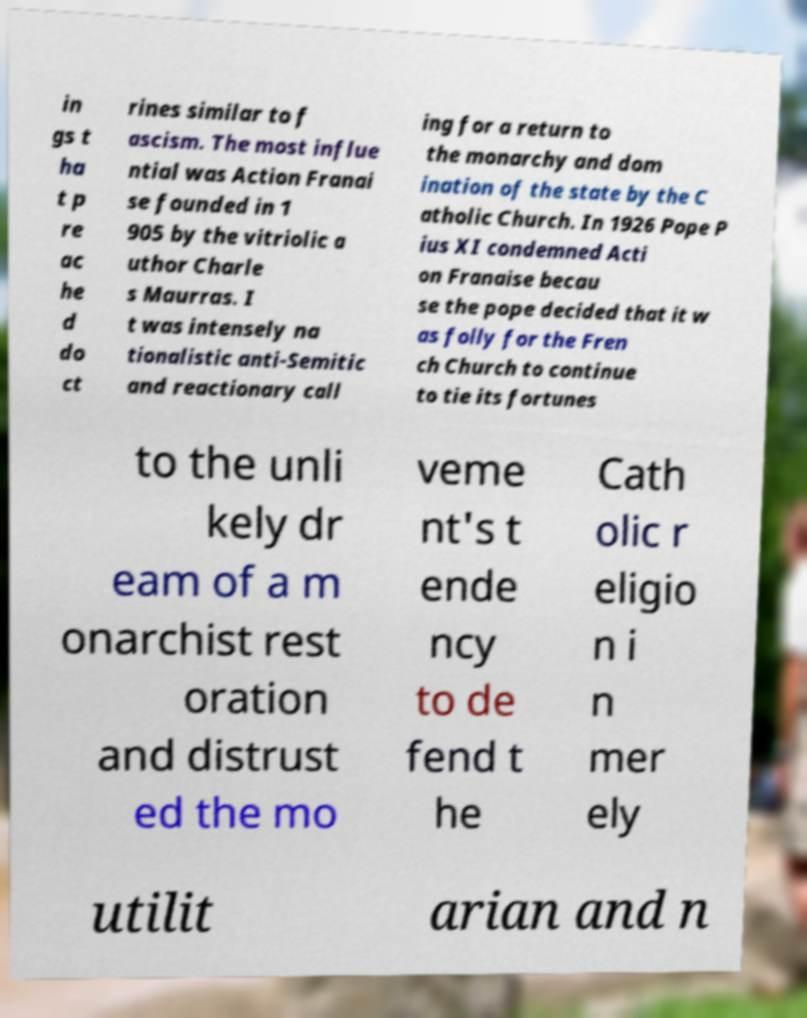There's text embedded in this image that I need extracted. Can you transcribe it verbatim? in gs t ha t p re ac he d do ct rines similar to f ascism. The most influe ntial was Action Franai se founded in 1 905 by the vitriolic a uthor Charle s Maurras. I t was intensely na tionalistic anti-Semitic and reactionary call ing for a return to the monarchy and dom ination of the state by the C atholic Church. In 1926 Pope P ius XI condemned Acti on Franaise becau se the pope decided that it w as folly for the Fren ch Church to continue to tie its fortunes to the unli kely dr eam of a m onarchist rest oration and distrust ed the mo veme nt's t ende ncy to de fend t he Cath olic r eligio n i n mer ely utilit arian and n 